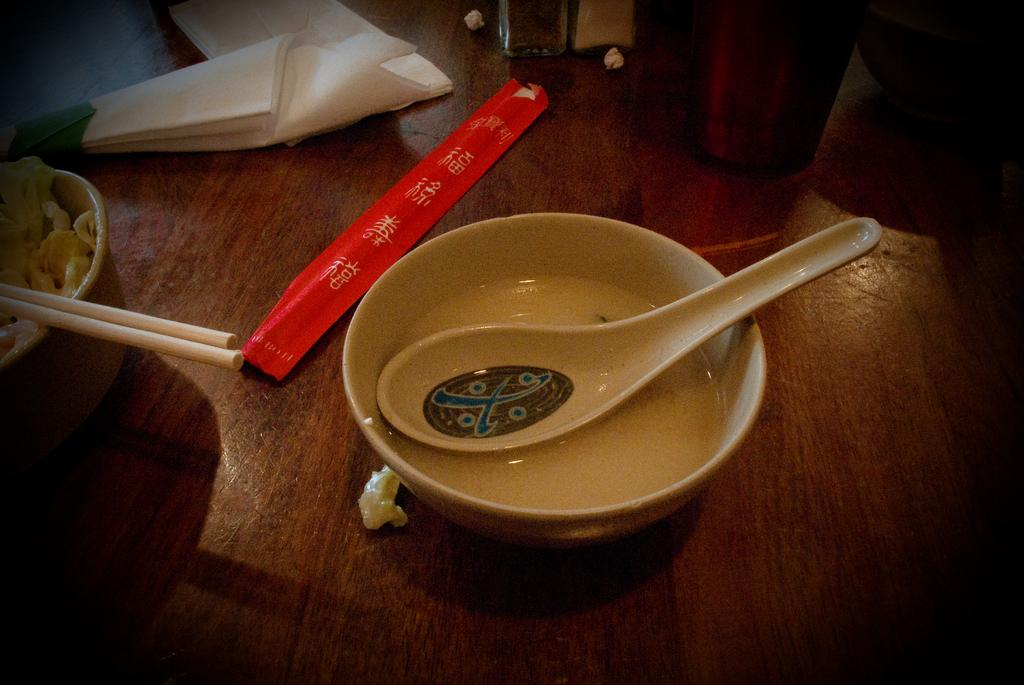What is in the bowl that is visible in the image? There is a bowl of soap in the image. Where is the bowl of soap located in the image? The bowl of soap is placed on a table. What is in the cup that is visible in the image? There is a cup of noodles in the image. What utensil is used with the cup of noodles? The cup of noodles has chopsticks in it. What can be used for cleaning or wiping in the image? Tissue papers are present in the image. What type of insurance is being discussed in the image? There is no discussion of insurance in the image; it features a bowl of soap, a cup of noodles, chopsticks, and tissue papers. What animal can be seen interacting with the bowl of soap in the image? There is no animal present in the image; it only features a bowl of soap, a cup of noodles, chopsticks, and tissue papers. 